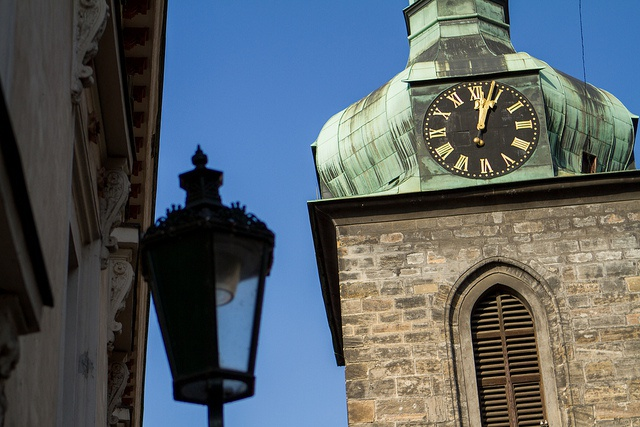Describe the objects in this image and their specific colors. I can see a clock in black and gray tones in this image. 